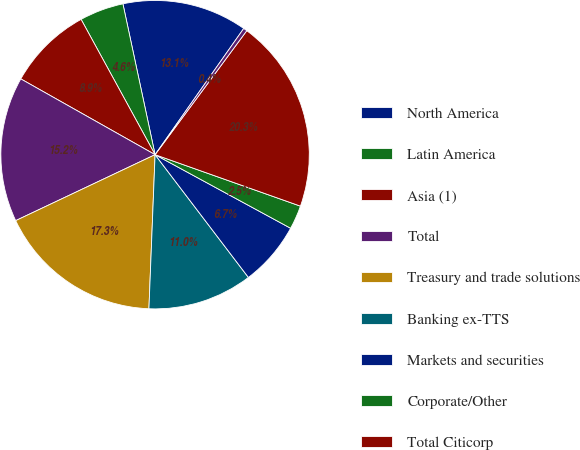<chart> <loc_0><loc_0><loc_500><loc_500><pie_chart><fcel>North America<fcel>Latin America<fcel>Asia (1)<fcel>Total<fcel>Treasury and trade solutions<fcel>Banking ex-TTS<fcel>Markets and securities<fcel>Corporate/Other<fcel>Total Citicorp<fcel>Total Citi Holdings<nl><fcel>13.09%<fcel>4.62%<fcel>8.86%<fcel>15.21%<fcel>17.33%<fcel>10.98%<fcel>6.74%<fcel>2.5%<fcel>20.28%<fcel>0.39%<nl></chart> 